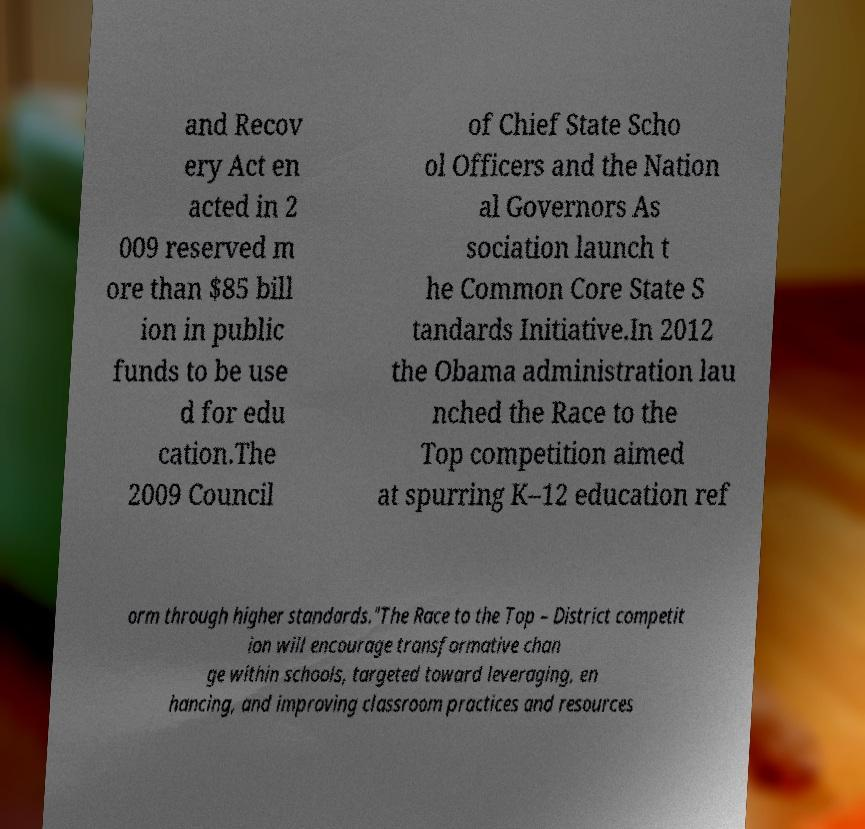For documentation purposes, I need the text within this image transcribed. Could you provide that? and Recov ery Act en acted in 2 009 reserved m ore than $85 bill ion in public funds to be use d for edu cation.The 2009 Council of Chief State Scho ol Officers and the Nation al Governors As sociation launch t he Common Core State S tandards Initiative.In 2012 the Obama administration lau nched the Race to the Top competition aimed at spurring K–12 education ref orm through higher standards."The Race to the Top – District competit ion will encourage transformative chan ge within schools, targeted toward leveraging, en hancing, and improving classroom practices and resources 